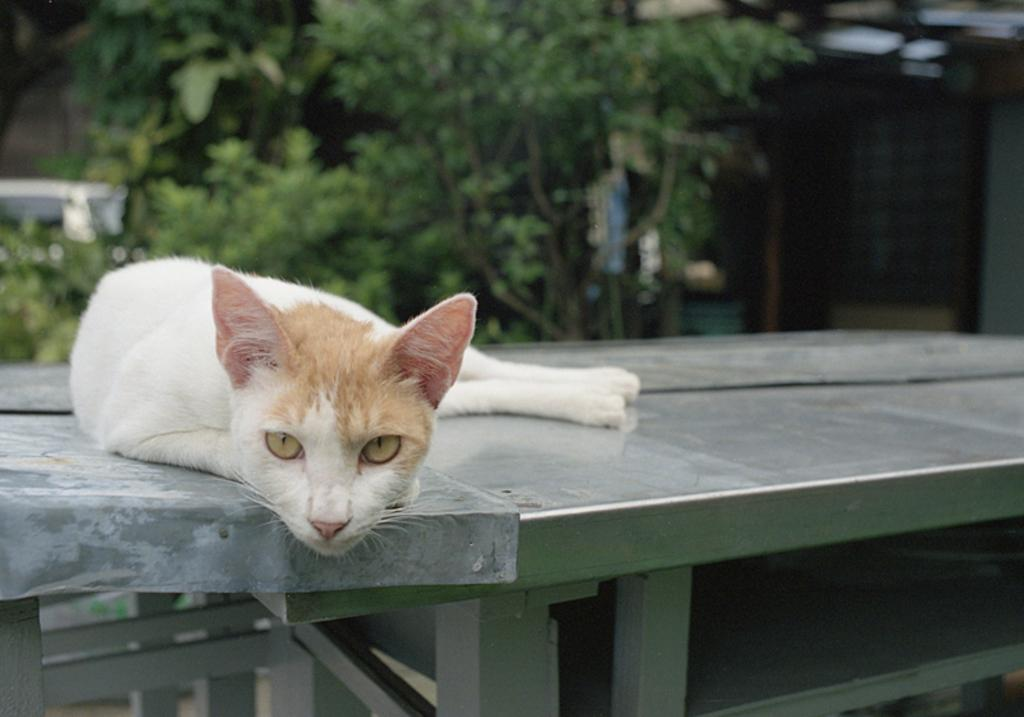What type of animal is in the image? There is a cat in the image. What is the cat doing in the image? The cat is laying on a bench. What can be seen in the background of the image? There are trees in the background of the image. What type of floor can be seen in the image? There is no floor visible in the image; the cat is laying on a bench. 